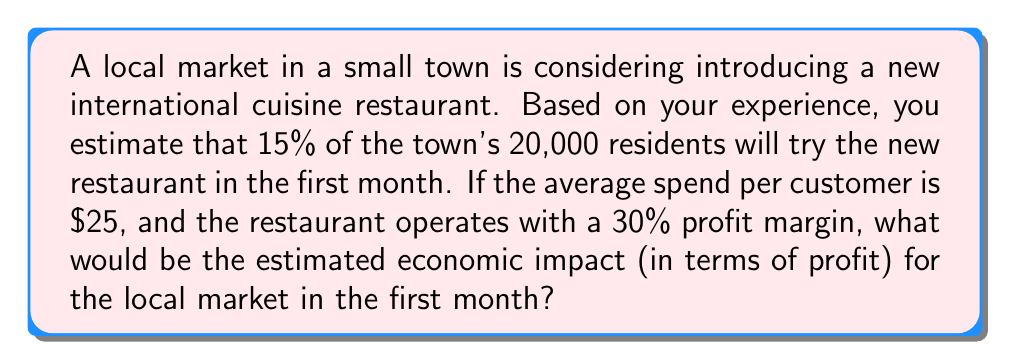What is the answer to this math problem? Let's break this down step-by-step:

1. Calculate the number of customers:
   $$ \text{Number of customers} = 15\% \times 20,000 = 0.15 \times 20,000 = 3,000 $$

2. Calculate the total revenue:
   $$ \text{Total revenue} = \text{Number of customers} \times \text{Average spend per customer} $$
   $$ \text{Total revenue} = 3,000 \times \$25 = \$75,000 $$

3. Calculate the profit:
   $$ \text{Profit} = \text{Total revenue} \times \text{Profit margin} $$
   $$ \text{Profit} = \$75,000 \times 30\% = \$75,000 \times 0.30 = \$22,500 $$

Therefore, the estimated economic impact in terms of profit for the local market in the first month would be $22,500.
Answer: $22,500 